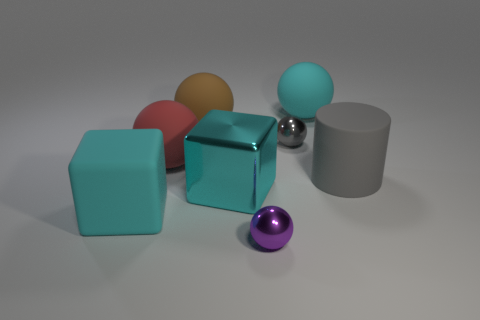Is the number of large gray things that are to the right of the large gray object greater than the number of tiny gray shiny spheres that are to the left of the large metallic object?
Make the answer very short. No. There is a big cyan thing that is made of the same material as the purple sphere; what is its shape?
Provide a short and direct response. Cube. How many other objects are there of the same shape as the big red thing?
Ensure brevity in your answer.  4. There is a big cyan rubber object that is to the left of the tiny purple metal object; what is its shape?
Make the answer very short. Cube. What color is the big metallic object?
Provide a succinct answer. Cyan. How many other things are there of the same size as the cyan sphere?
Provide a succinct answer. 5. What is the material of the tiny ball behind the tiny shiny sphere in front of the gray matte cylinder?
Offer a terse response. Metal. There is a cyan matte sphere; is its size the same as the metal object in front of the big cyan shiny object?
Give a very brief answer. No. Are there any big rubber objects of the same color as the big shiny cube?
Provide a succinct answer. Yes. How many big objects are either gray objects or brown things?
Keep it short and to the point. 2. 